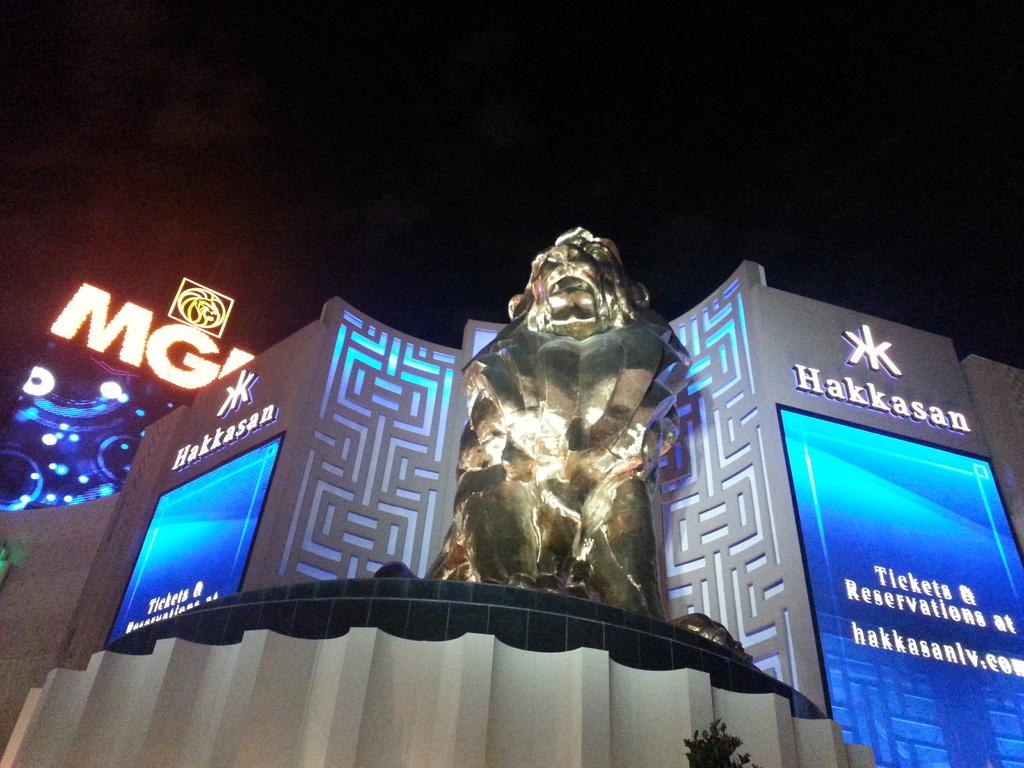<image>
Write a terse but informative summary of the picture. A large silver statue outside the Hakkasan hotel 